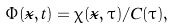<formula> <loc_0><loc_0><loc_500><loc_500>\Phi ( \vec { x } , t ) = \chi ( \vec { x } , \tau ) / C ( \tau ) ,</formula> 